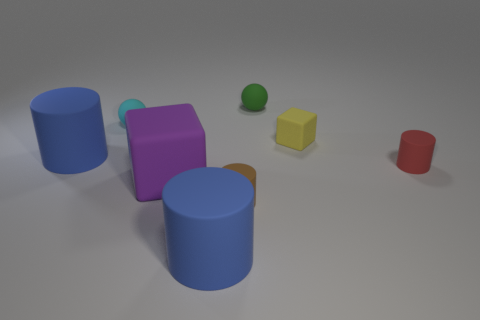The purple object that is made of the same material as the yellow thing is what shape?
Offer a very short reply. Cube. How many other objects are the same shape as the small red rubber object?
Give a very brief answer. 3. Is the number of balls to the right of the cyan matte object greater than the number of purple spheres?
Provide a succinct answer. Yes. The red object that is the same shape as the small brown thing is what size?
Your response must be concise. Small. What is the shape of the big purple thing?
Keep it short and to the point. Cube. The yellow thing that is the same size as the green ball is what shape?
Provide a short and direct response. Cube. Is there anything else of the same color as the small block?
Keep it short and to the point. No. What is the size of the purple cube that is made of the same material as the tiny brown thing?
Make the answer very short. Large. There is a cyan object; is it the same shape as the large thing that is behind the purple block?
Your response must be concise. No. What size is the green object?
Keep it short and to the point. Small. 